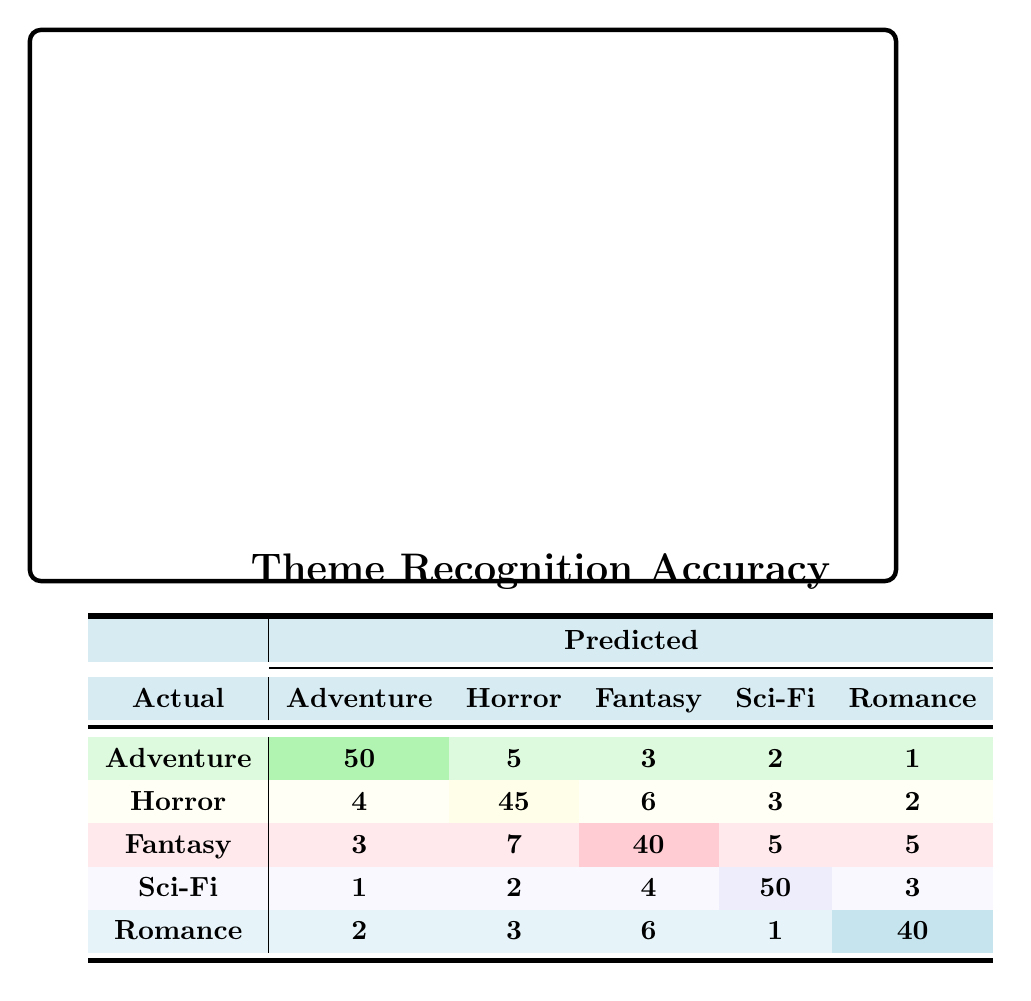What is the predicted number of Horror themes classified as Adventure? According to the confusion matrix, the predicted number of Horror themes classified as Adventure is 4.
Answer: 4 What is the value of true positives for the Fantasy theme? The true positive for the Fantasy theme is represented in the cell where the actual and predicted classes match, which is 40.
Answer: 40 How many total Sci-Fi theme predictions were made? The total predictions for the Sci-Fi theme can be calculated by summing all values in the Sci-Fi column: 1 + 2 + 4 + 50 + 3 = 60.
Answer: 60 Are more Adventure themes predicted than Romance themes? By comparing the numbers, Adventure has 50 predicted accurately while Romance has 40, which means more Adventure themes are predicted than Romance themes.
Answer: Yes What is the overall accuracy of the prediction for the Romance theme? The accuracy for the Romance theme can be calculated using the true positives (40) divided by the total of actual Romance predictions (2 + 3 + 6 + 1 + 40 = 52), which results in 40/52 = 0.7692, or about 76.92%.
Answer: 76.92% What is the sum of the predictions for the Fantasy theme? The predictions for the Fantasy theme are 3 (Adventure) + 7 (Horror) + 40 (Fantasy) + 5 (Sci-Fi) + 5 (Romance) = 60.
Answer: 60 Which theme has the highest number of accurate predictions? By reviewing the diagonal of the matrix, Adventure has 50, Horror has 45, Fantasy has 40, Sci-Fi has 50, and Romance has 40. Both Adventure and Sci-Fi themes have the highest number at 50.
Answer: Adventure and Sci-Fi What is the total number of misclassifications for the Horror theme? The misclassifications for the Horror theme can be calculated by summing the values in the Horror row, excluding the correct prediction: 4 (Adventure) + 6 (Fantasy) + 3 (Sci-Fi) + 2 (Romance) = 15.
Answer: 15 Is the number of misclassified Romance themes less than the total number of misclassified Adventure themes? The misclassifications for Romance sum to 2 + 3 + 6 + 1 = 12, and for Adventure they sum to 5 + 3 + 2 + 1 = 11, so the misclassified Romance themes are greater than the Adventure themes.
Answer: No 